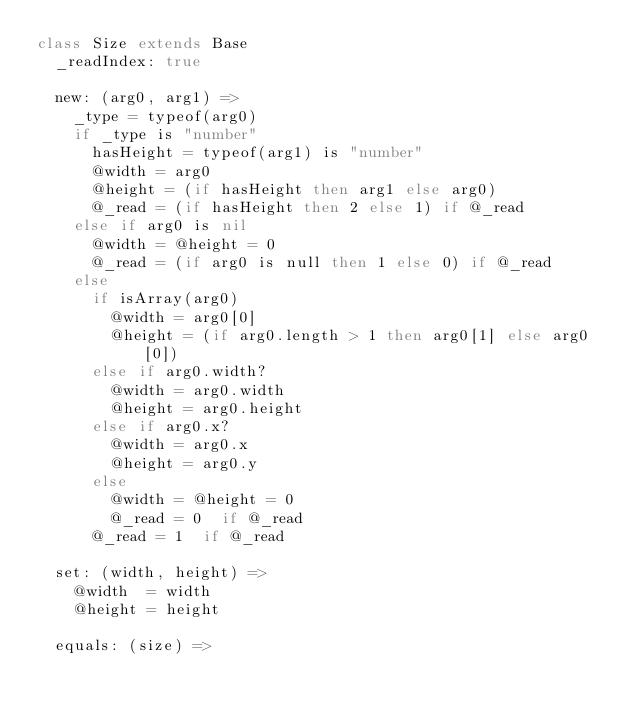<code> <loc_0><loc_0><loc_500><loc_500><_MoonScript_>class Size extends Base
	_readIndex: true

	new: (arg0, arg1) =>
    _type = typeof(arg0)
    if _type is "number"
      hasHeight = typeof(arg1) is "number"
      @width = arg0
      @height = (if hasHeight then arg1 else arg0)
      @_read = (if hasHeight then 2 else 1) if @_read
    else if arg0 is nil
      @width = @height = 0
      @_read = (if arg0 is null then 1 else 0) if @_read
    else
      if isArray(arg0)
        @width = arg0[0]
        @height = (if arg0.length > 1 then arg0[1] else arg0[0])
      else if arg0.width?
        @width = arg0.width
        @height = arg0.height
      else if arg0.x?
        @width = arg0.x
        @height = arg0.y
      else
        @width = @height = 0
        @_read = 0  if @_read
      @_read = 1  if @_read

  set: (width, height) =>
    @width  = width
    @height = height

  equals: (size) =></code> 